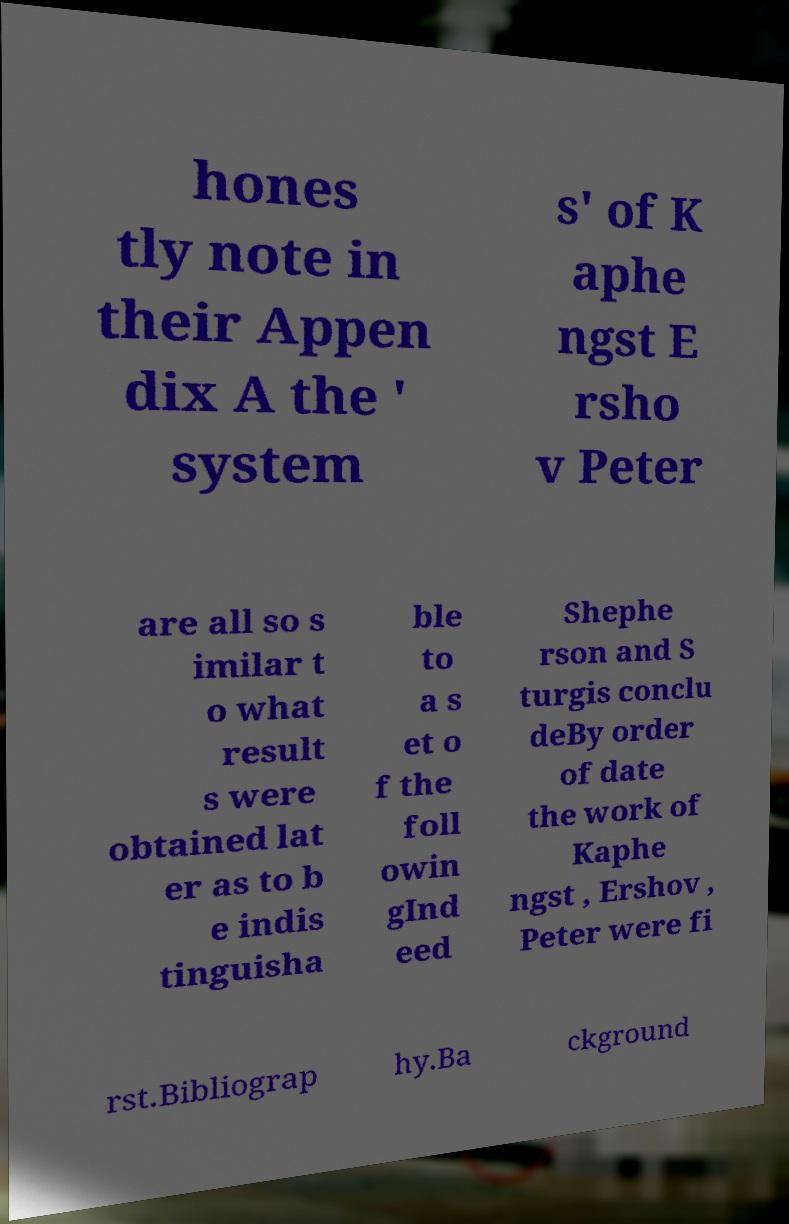There's text embedded in this image that I need extracted. Can you transcribe it verbatim? hones tly note in their Appen dix A the ' system s' of K aphe ngst E rsho v Peter are all so s imilar t o what result s were obtained lat er as to b e indis tinguisha ble to a s et o f the foll owin gInd eed Shephe rson and S turgis conclu deBy order of date the work of Kaphe ngst , Ershov , Peter were fi rst.Bibliograp hy.Ba ckground 